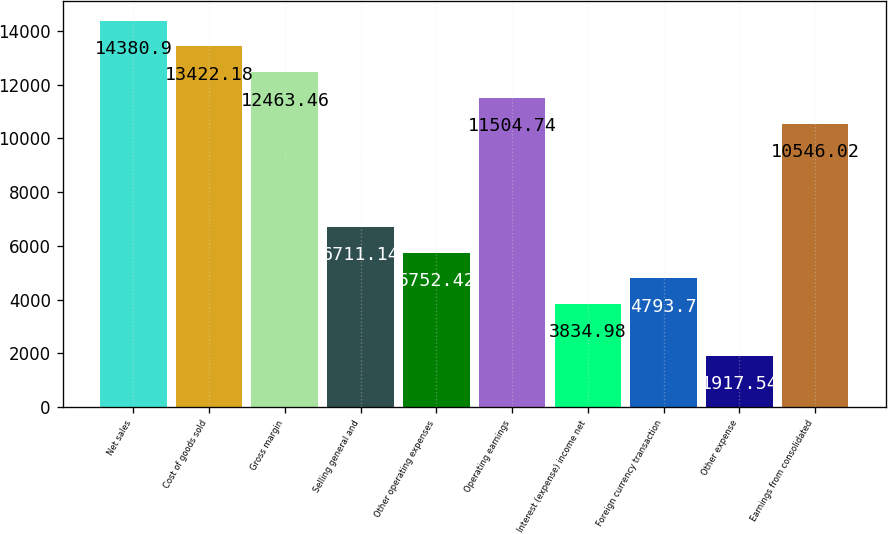Convert chart. <chart><loc_0><loc_0><loc_500><loc_500><bar_chart><fcel>Net sales<fcel>Cost of goods sold<fcel>Gross margin<fcel>Selling general and<fcel>Other operating expenses<fcel>Operating earnings<fcel>Interest (expense) income net<fcel>Foreign currency transaction<fcel>Other expense<fcel>Earnings from consolidated<nl><fcel>14380.9<fcel>13422.2<fcel>12463.5<fcel>6711.14<fcel>5752.42<fcel>11504.7<fcel>3834.98<fcel>4793.7<fcel>1917.54<fcel>10546<nl></chart> 